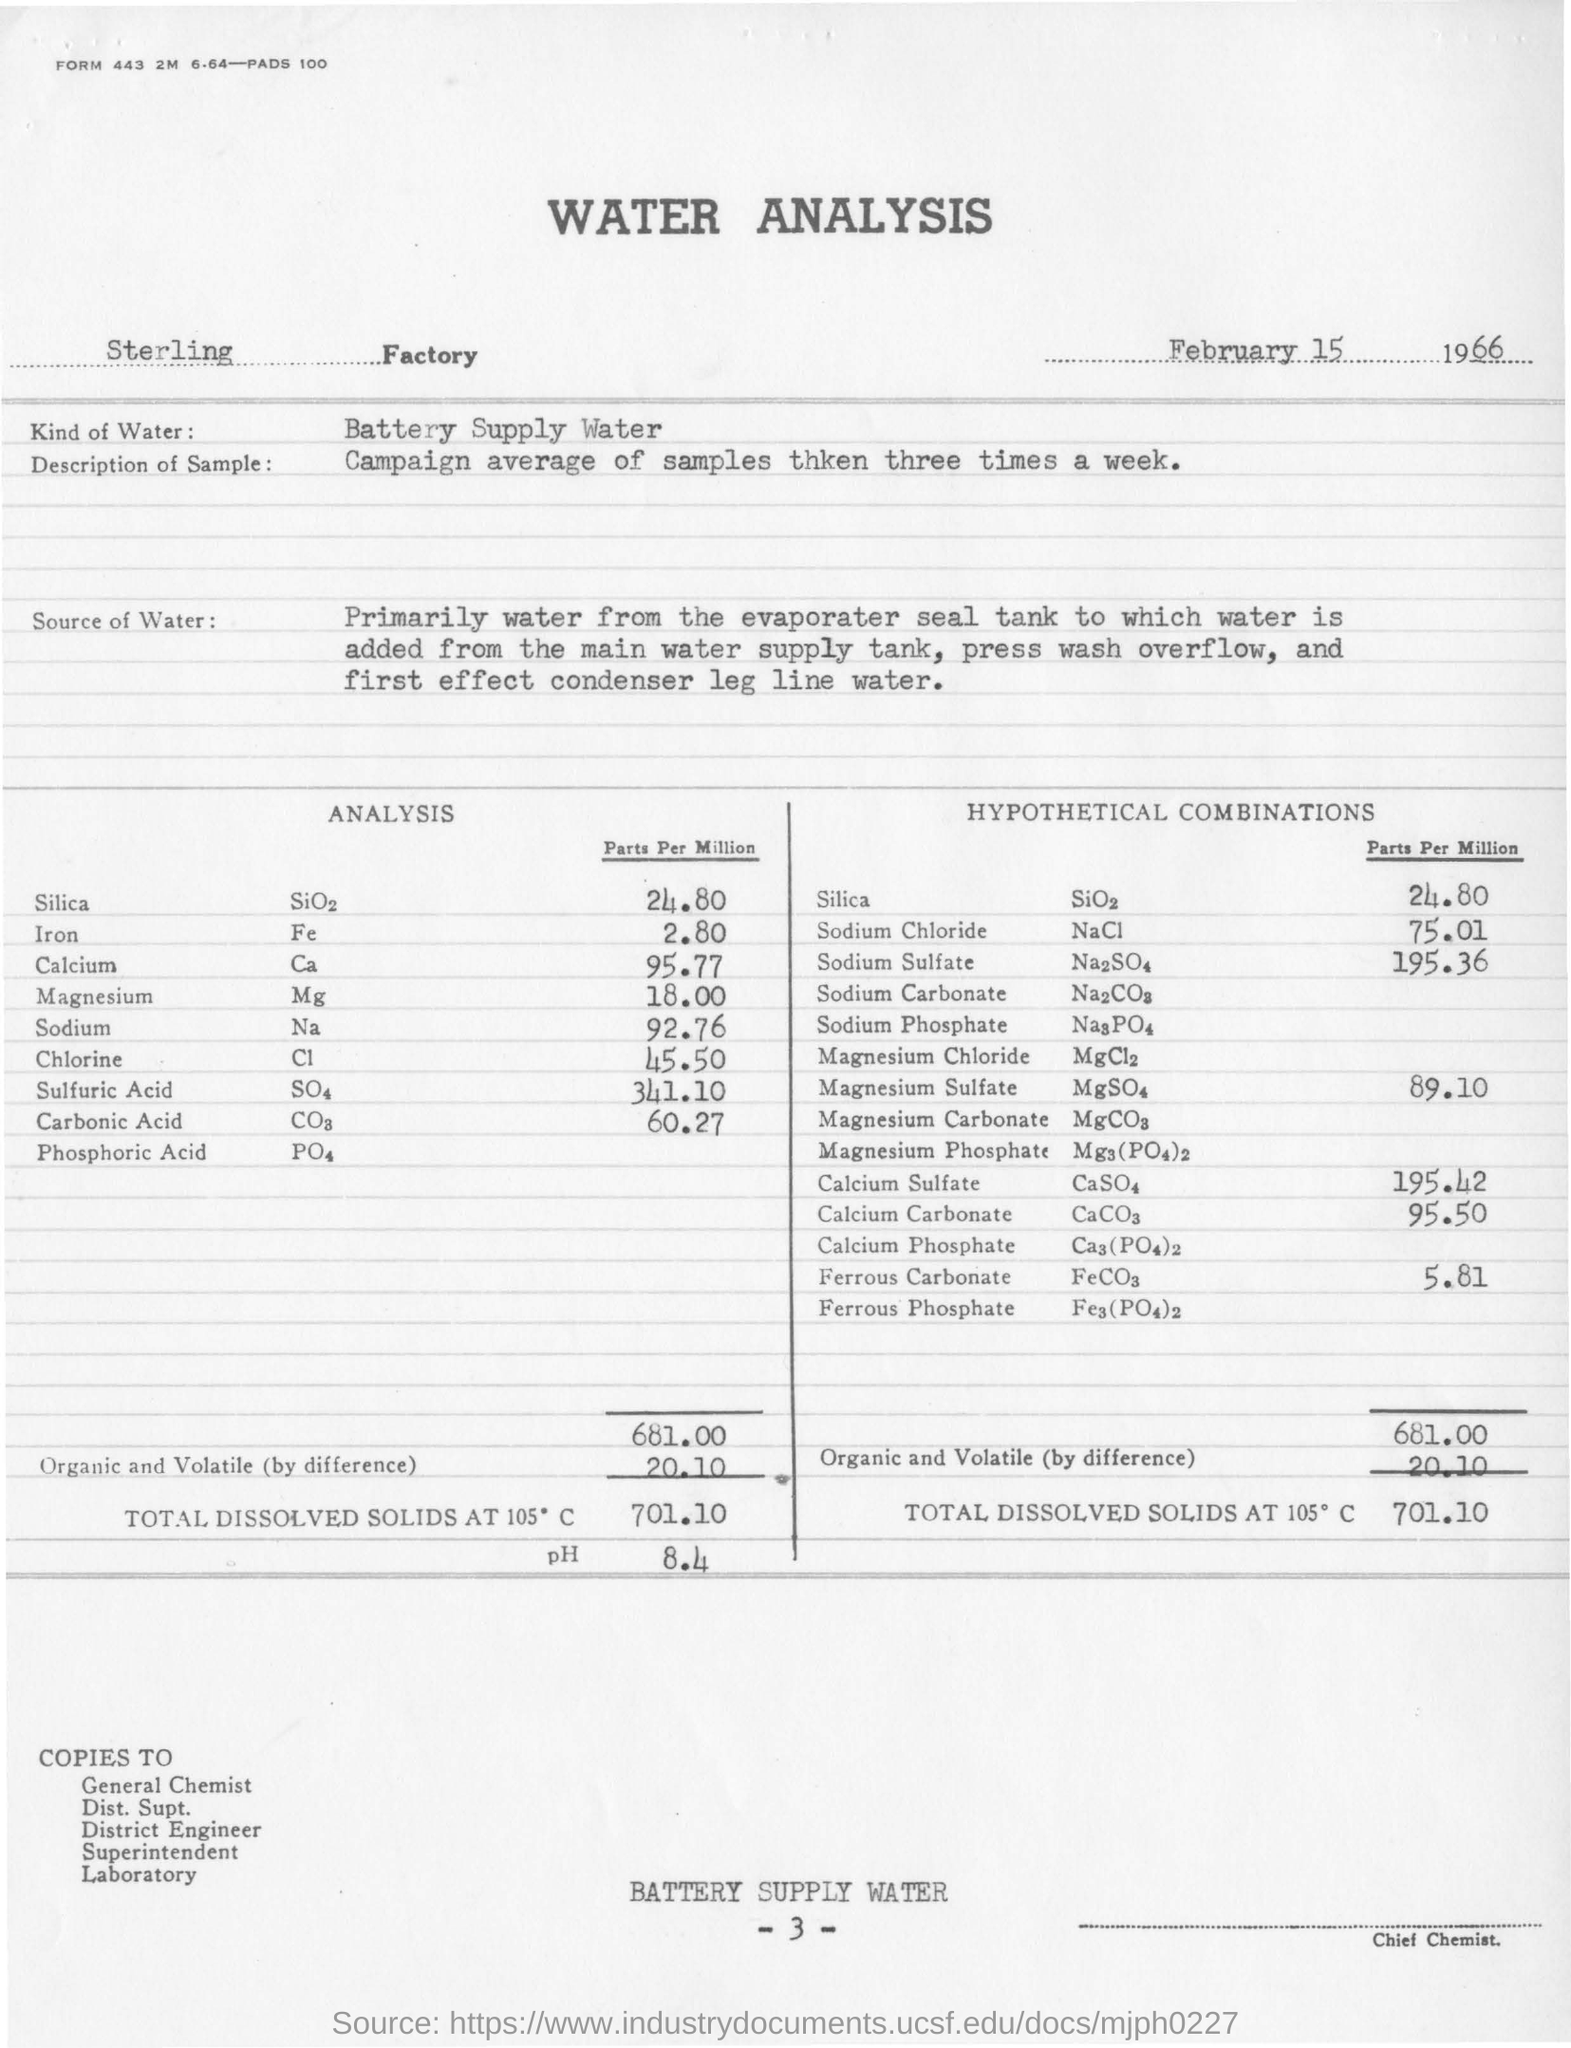What is the title?
Make the answer very short. Water Analysis. What factory is it?
Provide a short and direct response. Sterling. What is the date mentioned here?
Your response must be concise. February 15 1966. What is the kind of water?
Offer a very short reply. Battery Supply Water. What is the description of sample?
Your response must be concise. Campaign average of samples thken three times a week. How much is the parts per million of silica?
Offer a terse response. 24.80. What is the chemical name for iron?
Offer a terse response. Fe. How much is the total dissolved solids at 105 degree celcius?
Ensure brevity in your answer.  701.10. Who should have signed the water analysis?
Provide a succinct answer. Chief chemist. 